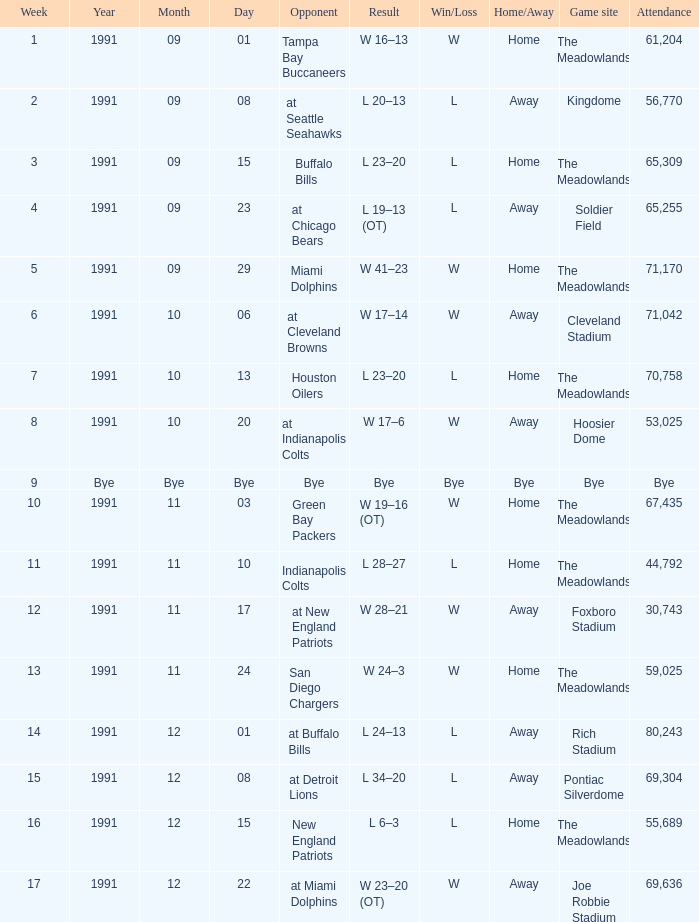What was the Result of the Game at the Meadowlands on 1991-09-01? W 16–13. 